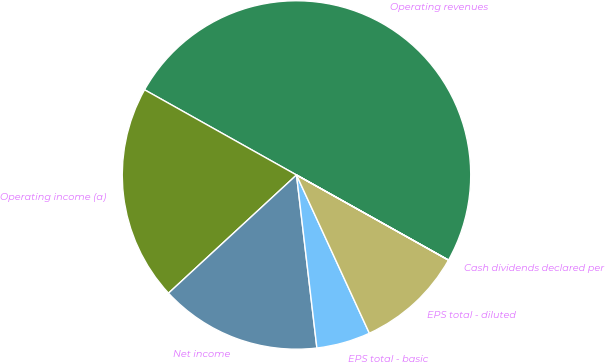<chart> <loc_0><loc_0><loc_500><loc_500><pie_chart><fcel>Operating revenues<fcel>Operating income (a)<fcel>Net income<fcel>EPS total - basic<fcel>EPS total - diluted<fcel>Cash dividends declared per<nl><fcel>49.99%<fcel>20.0%<fcel>15.0%<fcel>5.0%<fcel>10.0%<fcel>0.01%<nl></chart> 